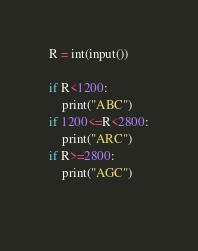<code> <loc_0><loc_0><loc_500><loc_500><_Python_>R = int(input())

if R<1200:
    print("ABC")
if 1200<=R<2800:
    print("ARC")
if R>=2800:
    print("AGC")
    </code> 